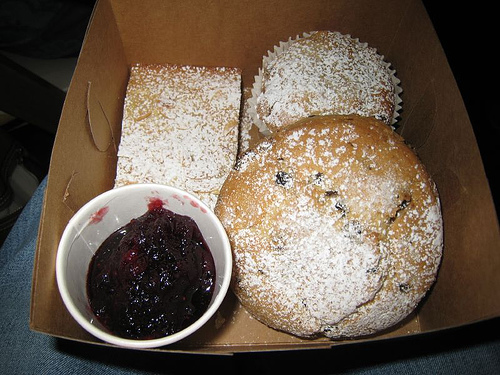<image>
Is there a jelly on the muffin? No. The jelly is not positioned on the muffin. They may be near each other, but the jelly is not supported by or resting on top of the muffin. 